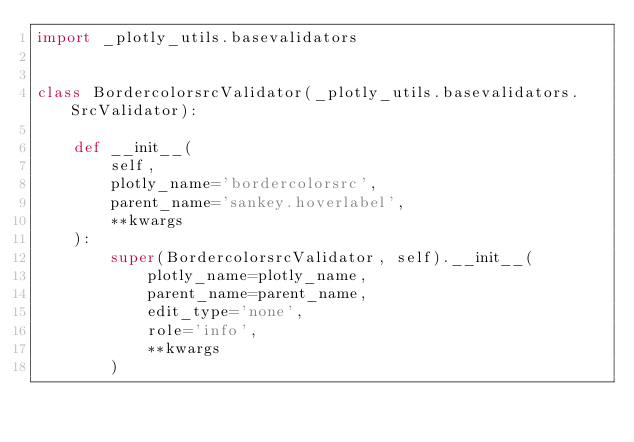<code> <loc_0><loc_0><loc_500><loc_500><_Python_>import _plotly_utils.basevalidators


class BordercolorsrcValidator(_plotly_utils.basevalidators.SrcValidator):

    def __init__(
        self,
        plotly_name='bordercolorsrc',
        parent_name='sankey.hoverlabel',
        **kwargs
    ):
        super(BordercolorsrcValidator, self).__init__(
            plotly_name=plotly_name,
            parent_name=parent_name,
            edit_type='none',
            role='info',
            **kwargs
        )
</code> 